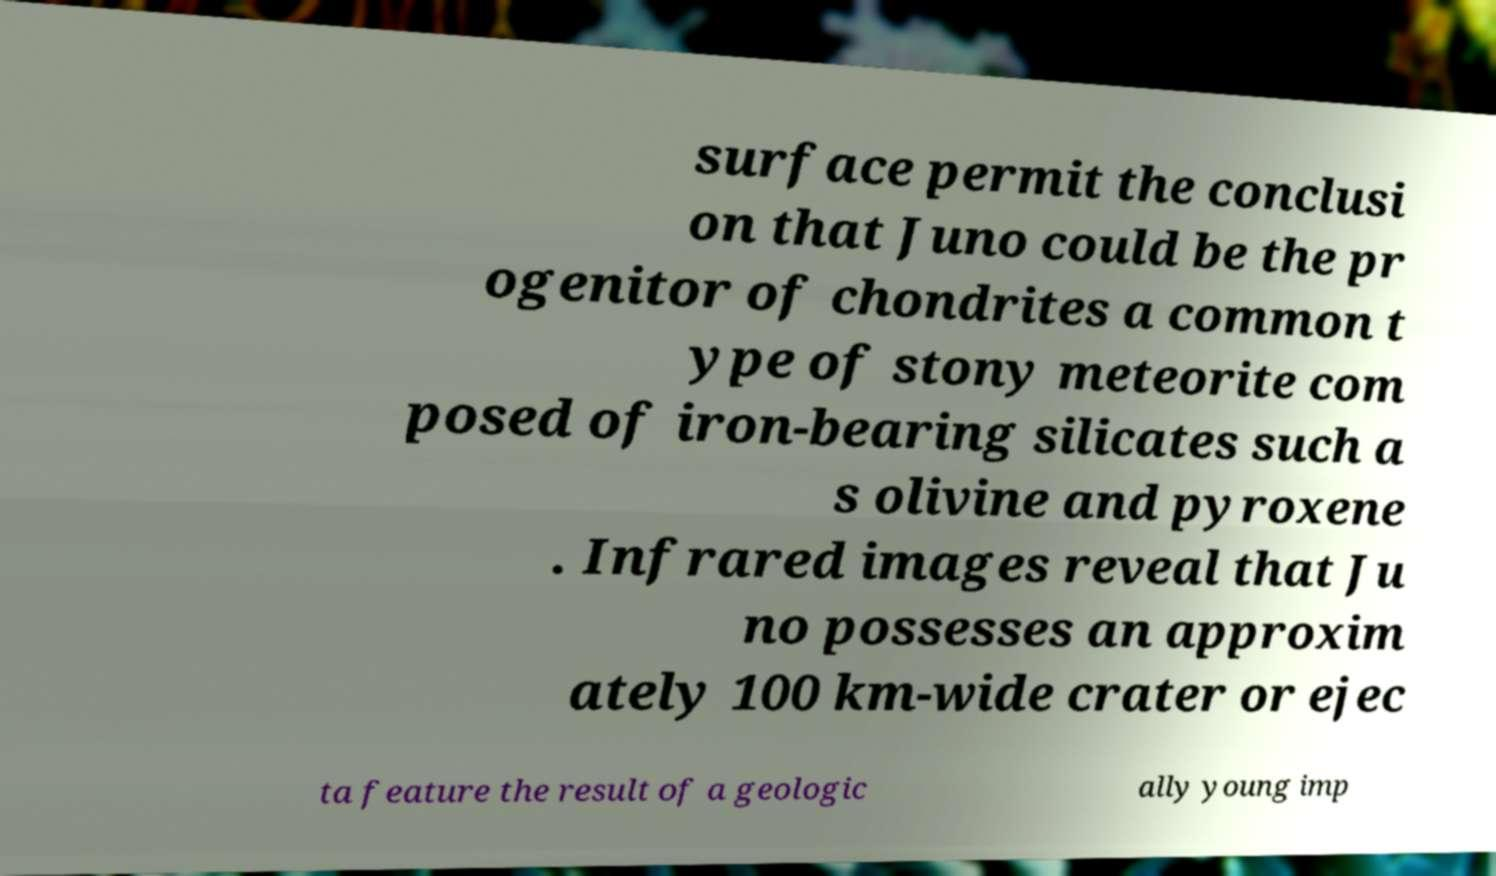There's text embedded in this image that I need extracted. Can you transcribe it verbatim? surface permit the conclusi on that Juno could be the pr ogenitor of chondrites a common t ype of stony meteorite com posed of iron-bearing silicates such a s olivine and pyroxene . Infrared images reveal that Ju no possesses an approxim ately 100 km-wide crater or ejec ta feature the result of a geologic ally young imp 